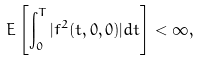Convert formula to latex. <formula><loc_0><loc_0><loc_500><loc_500>E \left [ \int _ { 0 } ^ { T } | f ^ { 2 } ( t , 0 , 0 ) | d t \right ] < \infty ,</formula> 